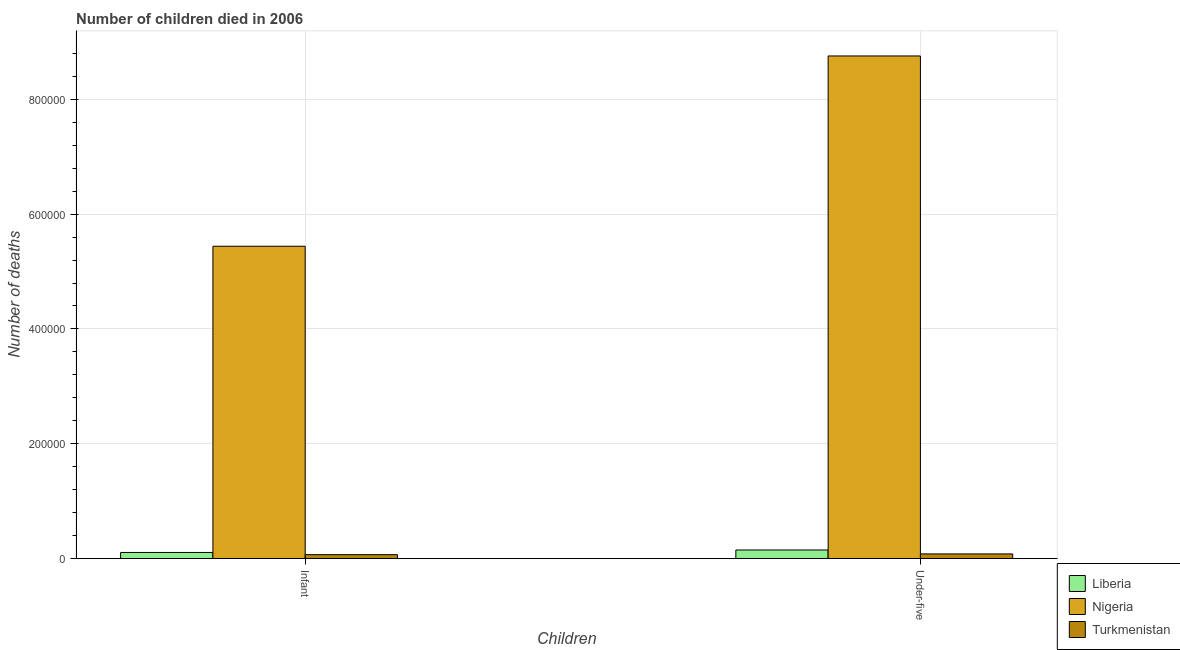How many groups of bars are there?
Offer a terse response. 2. How many bars are there on the 2nd tick from the left?
Your answer should be compact. 3. How many bars are there on the 2nd tick from the right?
Make the answer very short. 3. What is the label of the 2nd group of bars from the left?
Your answer should be very brief. Under-five. What is the number of infant deaths in Nigeria?
Your response must be concise. 5.44e+05. Across all countries, what is the maximum number of under-five deaths?
Your answer should be very brief. 8.76e+05. Across all countries, what is the minimum number of infant deaths?
Ensure brevity in your answer.  6812. In which country was the number of infant deaths maximum?
Your answer should be compact. Nigeria. In which country was the number of infant deaths minimum?
Ensure brevity in your answer.  Turkmenistan. What is the total number of infant deaths in the graph?
Provide a succinct answer. 5.62e+05. What is the difference between the number of infant deaths in Liberia and that in Nigeria?
Provide a short and direct response. -5.33e+05. What is the difference between the number of under-five deaths in Turkmenistan and the number of infant deaths in Liberia?
Ensure brevity in your answer.  -2532. What is the average number of infant deaths per country?
Your answer should be compact. 1.87e+05. What is the difference between the number of infant deaths and number of under-five deaths in Turkmenistan?
Your answer should be very brief. -1290. In how many countries, is the number of infant deaths greater than 480000 ?
Provide a short and direct response. 1. What is the ratio of the number of infant deaths in Liberia to that in Nigeria?
Give a very brief answer. 0.02. Is the number of infant deaths in Nigeria less than that in Liberia?
Your answer should be very brief. No. What does the 1st bar from the left in Infant represents?
Your answer should be very brief. Liberia. What does the 3rd bar from the right in Infant represents?
Your answer should be very brief. Liberia. How many bars are there?
Provide a succinct answer. 6. Are all the bars in the graph horizontal?
Your response must be concise. No. How many countries are there in the graph?
Ensure brevity in your answer.  3. Are the values on the major ticks of Y-axis written in scientific E-notation?
Give a very brief answer. No. Does the graph contain any zero values?
Your answer should be compact. No. Where does the legend appear in the graph?
Ensure brevity in your answer.  Bottom right. What is the title of the graph?
Provide a short and direct response. Number of children died in 2006. Does "Argentina" appear as one of the legend labels in the graph?
Your answer should be very brief. No. What is the label or title of the X-axis?
Your answer should be compact. Children. What is the label or title of the Y-axis?
Keep it short and to the point. Number of deaths. What is the Number of deaths in Liberia in Infant?
Provide a succinct answer. 1.06e+04. What is the Number of deaths of Nigeria in Infant?
Your answer should be very brief. 5.44e+05. What is the Number of deaths of Turkmenistan in Infant?
Provide a short and direct response. 6812. What is the Number of deaths in Liberia in Under-five?
Your response must be concise. 1.50e+04. What is the Number of deaths of Nigeria in Under-five?
Provide a succinct answer. 8.76e+05. What is the Number of deaths in Turkmenistan in Under-five?
Your response must be concise. 8102. Across all Children, what is the maximum Number of deaths in Liberia?
Give a very brief answer. 1.50e+04. Across all Children, what is the maximum Number of deaths in Nigeria?
Provide a short and direct response. 8.76e+05. Across all Children, what is the maximum Number of deaths of Turkmenistan?
Give a very brief answer. 8102. Across all Children, what is the minimum Number of deaths of Liberia?
Offer a very short reply. 1.06e+04. Across all Children, what is the minimum Number of deaths in Nigeria?
Give a very brief answer. 5.44e+05. Across all Children, what is the minimum Number of deaths in Turkmenistan?
Provide a short and direct response. 6812. What is the total Number of deaths of Liberia in the graph?
Provide a succinct answer. 2.56e+04. What is the total Number of deaths in Nigeria in the graph?
Offer a very short reply. 1.42e+06. What is the total Number of deaths of Turkmenistan in the graph?
Provide a short and direct response. 1.49e+04. What is the difference between the Number of deaths of Liberia in Infant and that in Under-five?
Make the answer very short. -4321. What is the difference between the Number of deaths in Nigeria in Infant and that in Under-five?
Offer a very short reply. -3.31e+05. What is the difference between the Number of deaths of Turkmenistan in Infant and that in Under-five?
Provide a short and direct response. -1290. What is the difference between the Number of deaths of Liberia in Infant and the Number of deaths of Nigeria in Under-five?
Keep it short and to the point. -8.65e+05. What is the difference between the Number of deaths of Liberia in Infant and the Number of deaths of Turkmenistan in Under-five?
Provide a short and direct response. 2532. What is the difference between the Number of deaths of Nigeria in Infant and the Number of deaths of Turkmenistan in Under-five?
Offer a terse response. 5.36e+05. What is the average Number of deaths of Liberia per Children?
Give a very brief answer. 1.28e+04. What is the average Number of deaths in Nigeria per Children?
Provide a short and direct response. 7.10e+05. What is the average Number of deaths in Turkmenistan per Children?
Your answer should be compact. 7457. What is the difference between the Number of deaths in Liberia and Number of deaths in Nigeria in Infant?
Offer a terse response. -5.33e+05. What is the difference between the Number of deaths of Liberia and Number of deaths of Turkmenistan in Infant?
Your response must be concise. 3822. What is the difference between the Number of deaths in Nigeria and Number of deaths in Turkmenistan in Infant?
Keep it short and to the point. 5.37e+05. What is the difference between the Number of deaths in Liberia and Number of deaths in Nigeria in Under-five?
Provide a short and direct response. -8.61e+05. What is the difference between the Number of deaths in Liberia and Number of deaths in Turkmenistan in Under-five?
Your response must be concise. 6853. What is the difference between the Number of deaths of Nigeria and Number of deaths of Turkmenistan in Under-five?
Provide a short and direct response. 8.67e+05. What is the ratio of the Number of deaths of Liberia in Infant to that in Under-five?
Your answer should be very brief. 0.71. What is the ratio of the Number of deaths of Nigeria in Infant to that in Under-five?
Give a very brief answer. 0.62. What is the ratio of the Number of deaths of Turkmenistan in Infant to that in Under-five?
Offer a very short reply. 0.84. What is the difference between the highest and the second highest Number of deaths of Liberia?
Ensure brevity in your answer.  4321. What is the difference between the highest and the second highest Number of deaths of Nigeria?
Your response must be concise. 3.31e+05. What is the difference between the highest and the second highest Number of deaths in Turkmenistan?
Make the answer very short. 1290. What is the difference between the highest and the lowest Number of deaths in Liberia?
Give a very brief answer. 4321. What is the difference between the highest and the lowest Number of deaths of Nigeria?
Your answer should be very brief. 3.31e+05. What is the difference between the highest and the lowest Number of deaths in Turkmenistan?
Provide a short and direct response. 1290. 